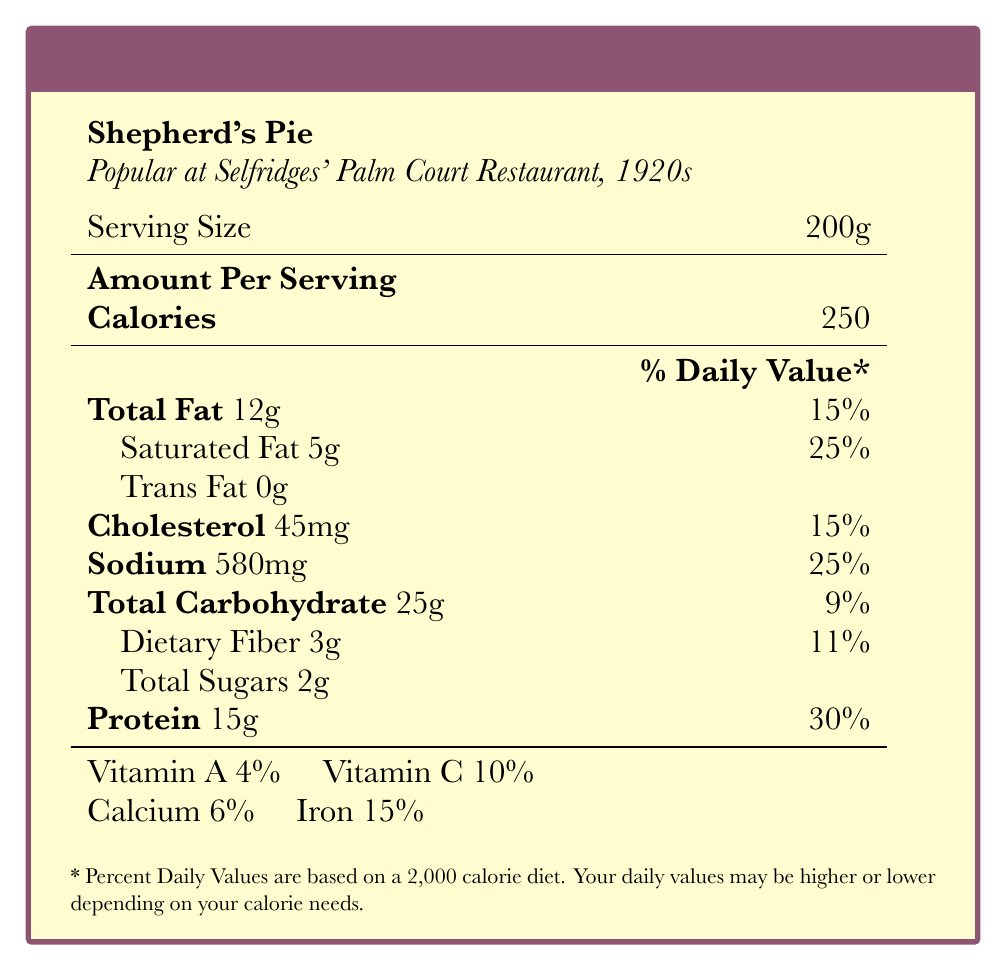what is the serving size of Shepherd's Pie? The document explicitly states that the serving size for Shepherd's Pie is 200g.
Answer: 200g how many grams of total fat does Shepherd's Pie contain? The nutritional facts list the total fat content of Shepherd's Pie as 12g.
Answer: 12g how many calories are in a serving of Shepherd's Pie? The calories per serving of Shepherd's Pie are listed as 250.
Answer: 250 what percentage of the daily value of iron does Shepherd's Pie provide? The nutritional information indicates that Shepherd's Pie provides 15% of the daily value of iron.
Answer: 15% does Shepherd's Pie contain any trans fat? The document lists 0g of trans fat in Shepherd's Pie, indicating it does not contain any trans fat.
Answer: No which nutrient has the highest percentage of daily value in Shepherd's Pie? A. Sodium B. Saturated Fat C. Protein D. Total Carbohydrate The percentage daily values for Saturated Fat, Sodium, Protein, and Total Carbohydrate are 25%, 25%, 30%, and 9%, respectively. Saturated Fat and Sodium both are 25%, but for the purpose of this question's correct distinct answer, the precise one is Saturated Fat.
Answer: B. Saturated Fat what is a historical note about Shepherd's Pie? The document mentions that Shepherd's Pie was popular at Selfridges' Palm Court Restaurant during the 1920s.
Answer: Popular at Selfridges' Palm Court Restaurant in the 1920s how much cholesterol is in one serving of Shepherd's Pie? A. 15mg B. 25mg C. 45mg D. 65mg The cholesterol content for Shepherd's Pie is listed as 45mg.
Answer: C. 45mg is there any dietary fiber in Shepherd's Pie? The document indicates that there are 3g of dietary fiber in Shepherd's Pie.
Answer: Yes summarize the nutritional information provided for Shepherd's Pie. This summary captures all the key nutritional elements and historical note about Shepherd's Pie as mentioned in the document.
Answer: Shepherd's Pie has a serving size of 200g containing 250 calories, 12g of total fat (5g of which are saturated), 0g trans fat, 45mg cholesterol, 580mg sodium, 25g total carbohydrate, 3g dietary fiber, 2g total sugars, and 15g protein. It provides 4% Vitamin A, 10% Vitamin C, 6% calcium, and 15% iron. It was popular at Selfridges' Palm Court Restaurant in the 1920s. what is the sugar content of Shepherd's Pie? The document specifies that Shepherd's Pie contains 2g of total sugars.
Answer: 2g does the document provide the ingredients for Shepherd's Pie? The document provides nutritional facts and historical notes but does not list the ingredients.
Answer: Not enough information 